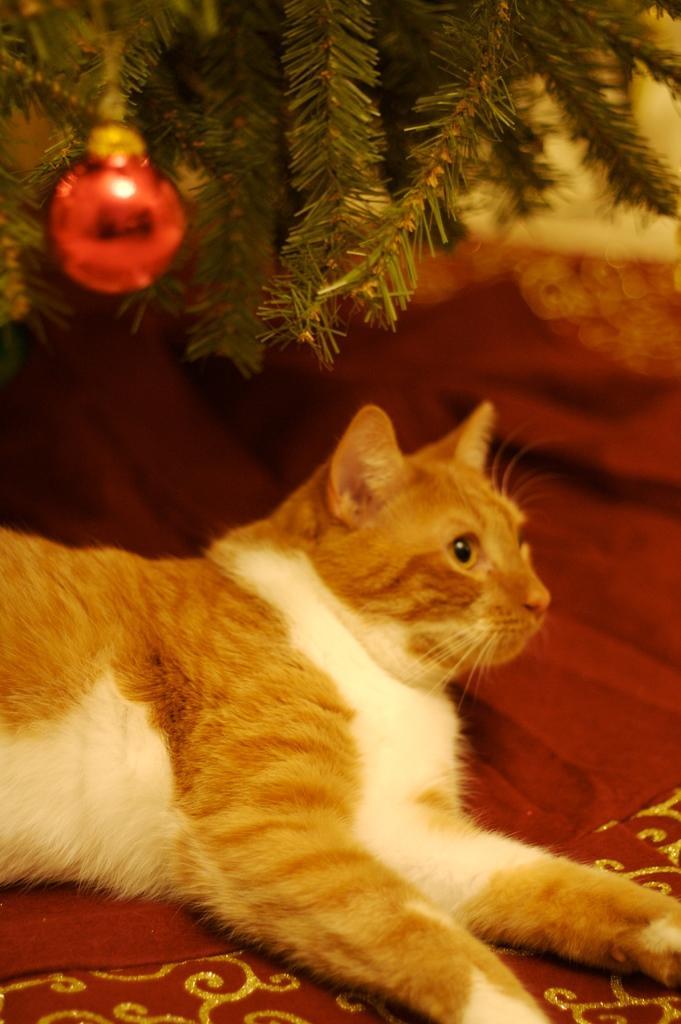Could you give a brief overview of what you see in this image? In the foreground of this image, there is a cat on a red color object. At the top, there is a red color ball hanging to a plant. 